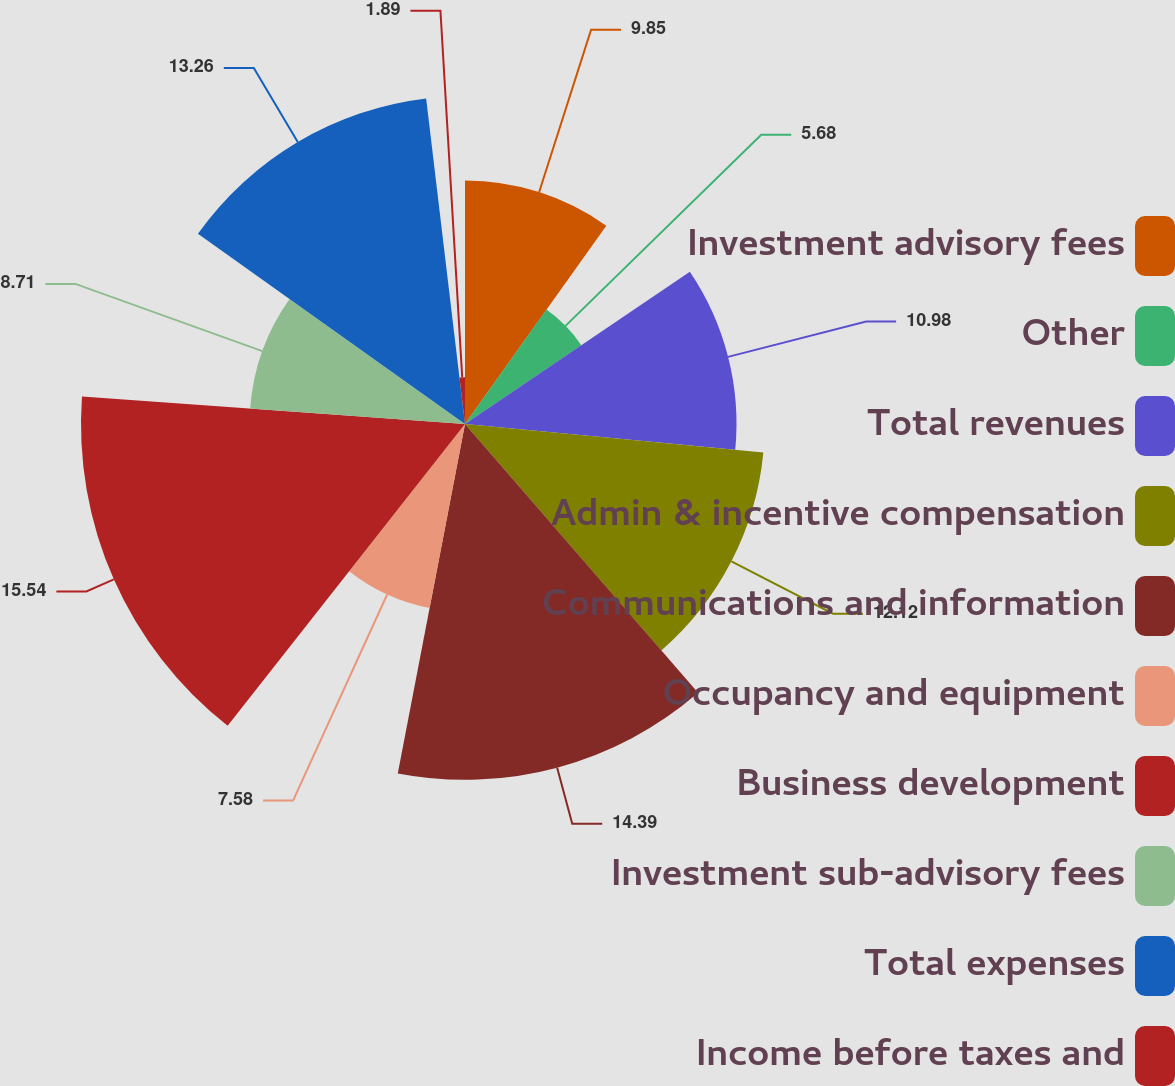Convert chart to OTSL. <chart><loc_0><loc_0><loc_500><loc_500><pie_chart><fcel>Investment advisory fees<fcel>Other<fcel>Total revenues<fcel>Admin & incentive compensation<fcel>Communications and information<fcel>Occupancy and equipment<fcel>Business development<fcel>Investment sub-advisory fees<fcel>Total expenses<fcel>Income before taxes and<nl><fcel>9.85%<fcel>5.68%<fcel>10.98%<fcel>12.12%<fcel>14.39%<fcel>7.58%<fcel>15.53%<fcel>8.71%<fcel>13.26%<fcel>1.89%<nl></chart> 